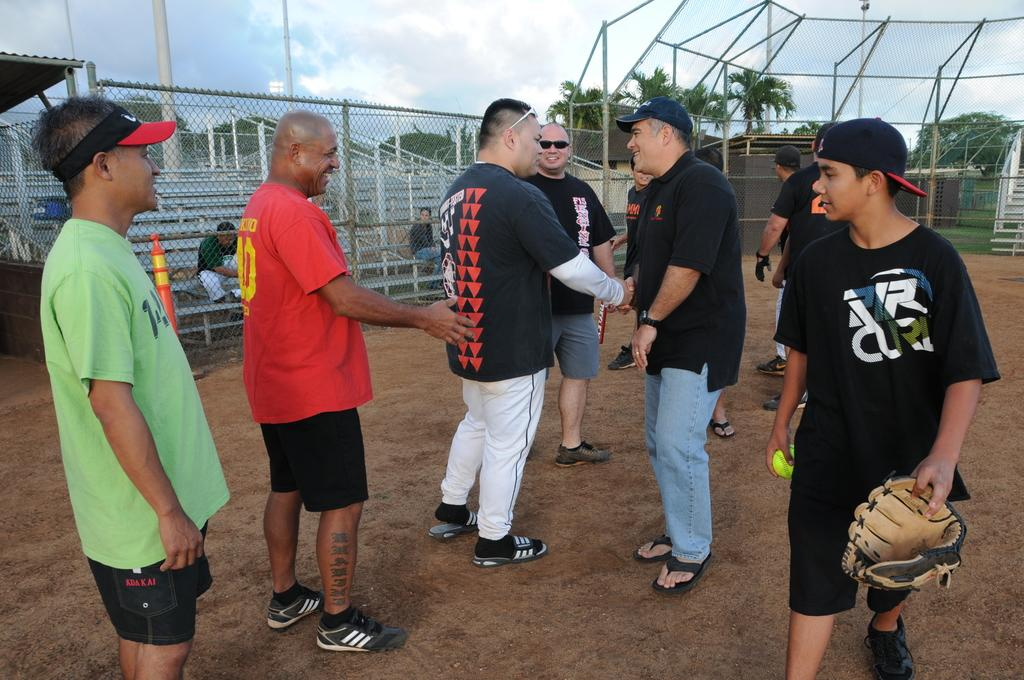<image>
Give a short and clear explanation of the subsequent image. A boy wearing a shirt that says Rip Curl watches some adults greet each other. 